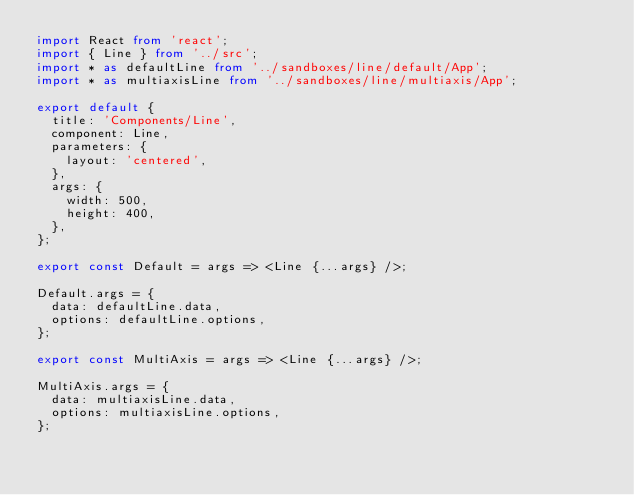Convert code to text. <code><loc_0><loc_0><loc_500><loc_500><_TypeScript_>import React from 'react';
import { Line } from '../src';
import * as defaultLine from '../sandboxes/line/default/App';
import * as multiaxisLine from '../sandboxes/line/multiaxis/App';

export default {
  title: 'Components/Line',
  component: Line,
  parameters: {
    layout: 'centered',
  },
  args: {
    width: 500,
    height: 400,
  },
};

export const Default = args => <Line {...args} />;

Default.args = {
  data: defaultLine.data,
  options: defaultLine.options,
};

export const MultiAxis = args => <Line {...args} />;

MultiAxis.args = {
  data: multiaxisLine.data,
  options: multiaxisLine.options,
};
</code> 